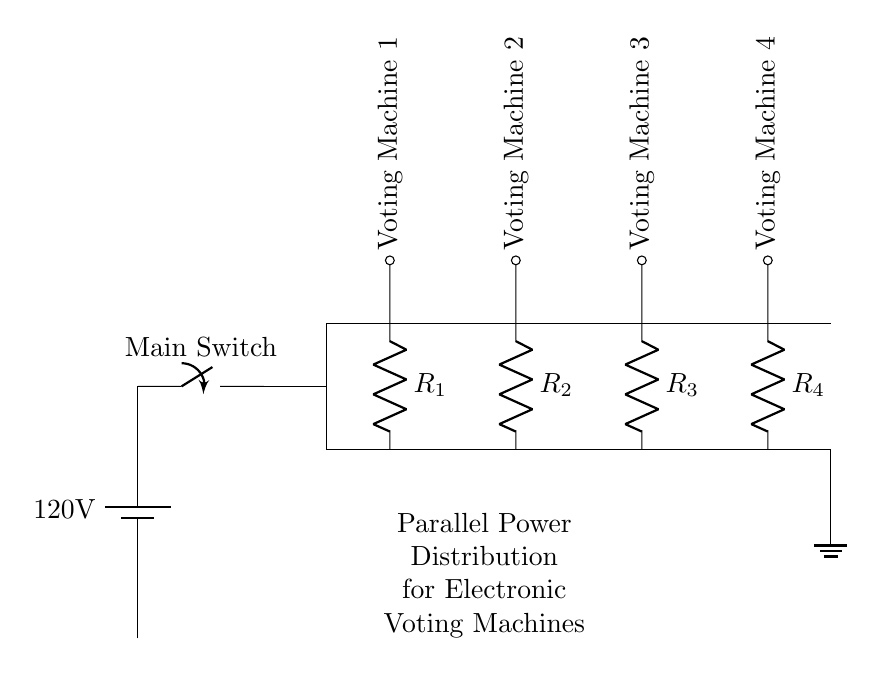What is the voltage of the power source? The circuit diagram indicates a battery labeled as a power source with a voltage of 120 volts, which is stated next to the battery symbol.
Answer: 120 volts How many voting machines are connected in this circuit? By examining the diagram, there are four voting machines depicted, each represented by a different labeled connection along the distribution lines.
Answer: Four What is the total number of resistors present in the circuit? The circuit shows four resistors, each associated with one of the voting machines, as denoted by labels attached to the resistor symbols in the diagram.
Answer: Four What type of circuit configuration is used to connect the voting machines? The diagram is structured such that all voting machines are connected in parallel to the power source, allowing each machine to operate independently while sharing the same voltage.
Answer: Parallel If one voting machine fails, how does it affect the others? In a parallel circuit, if one component (voting machine) fails, the others can continue to operate as they are not dependent on each other for current. This design ensures that the failure of one machine does not disrupt the function of the others.
Answer: Others continue to operate 